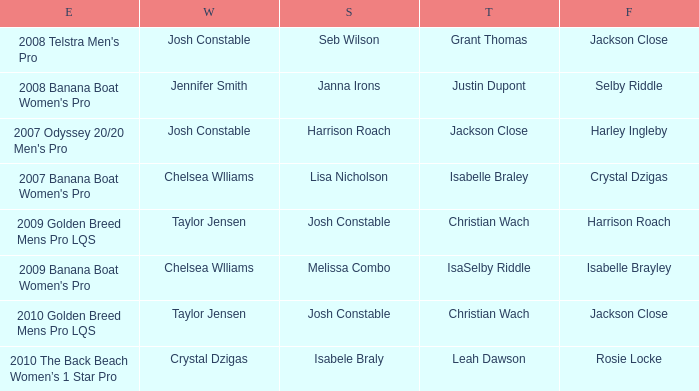Who came in fourth place at the 2008 telstra men's pro event? Jackson Close. 